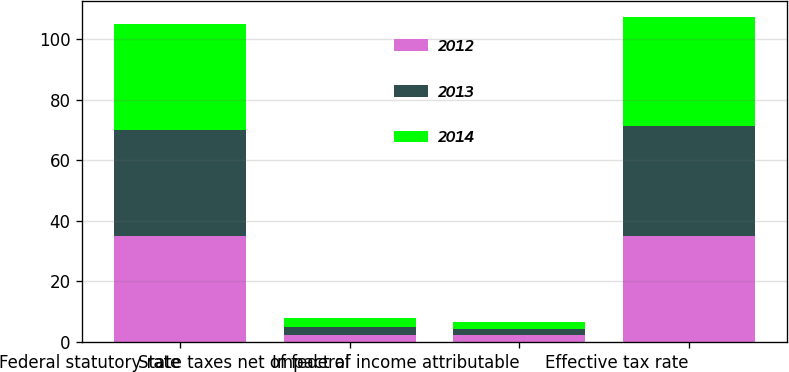<chart> <loc_0><loc_0><loc_500><loc_500><stacked_bar_chart><ecel><fcel>Federal statutory rate<fcel>State taxes net of federal<fcel>Impact of income attributable<fcel>Effective tax rate<nl><fcel>2012<fcel>35<fcel>2.3<fcel>2.4<fcel>34.9<nl><fcel>2013<fcel>35<fcel>2.5<fcel>1.9<fcel>36.3<nl><fcel>2014<fcel>35<fcel>3<fcel>2.3<fcel>36<nl></chart> 